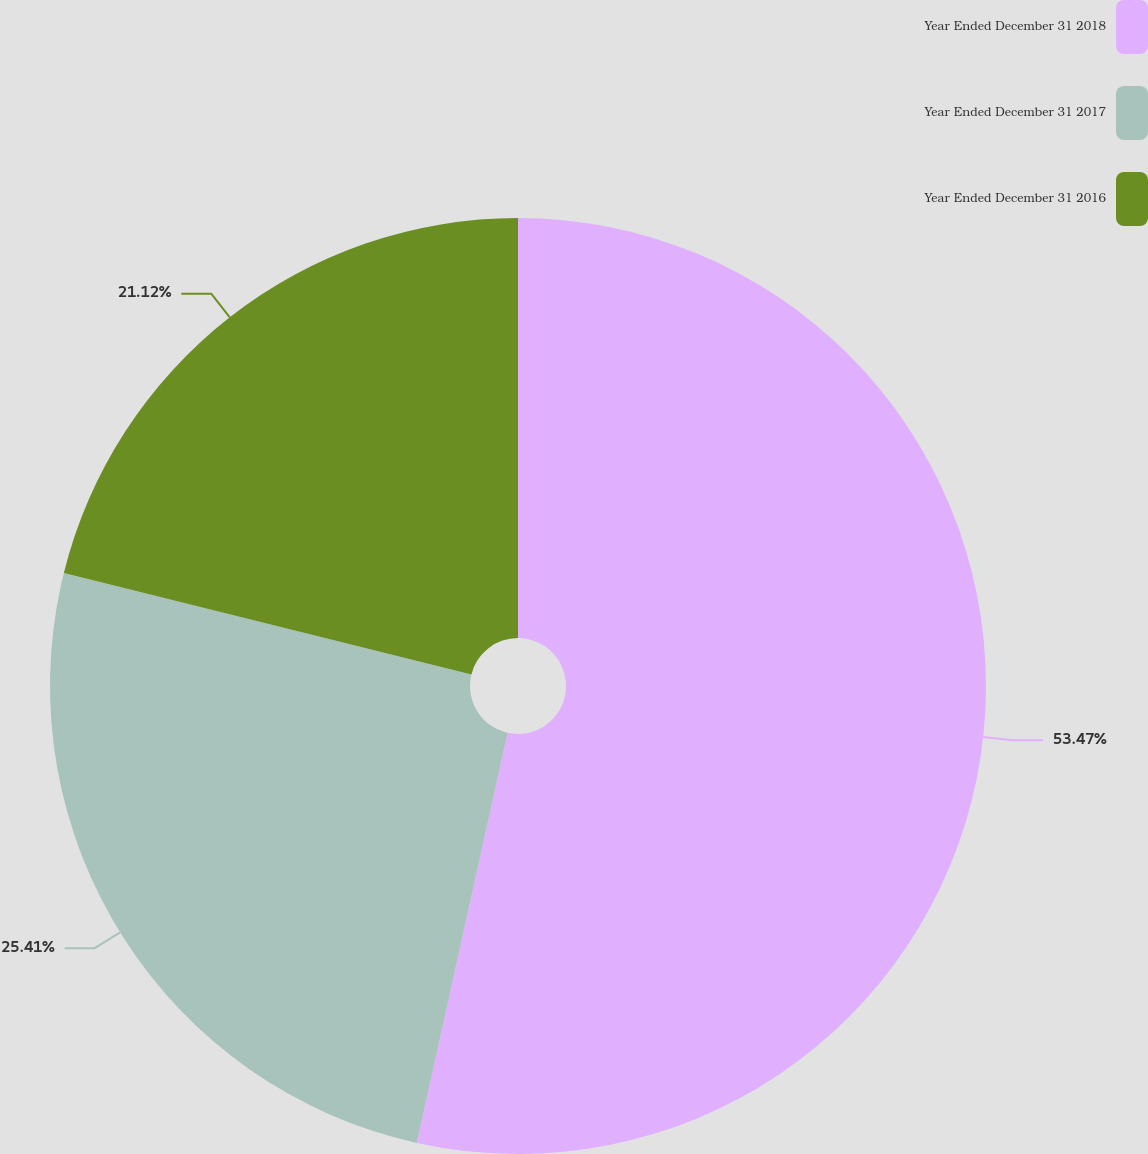<chart> <loc_0><loc_0><loc_500><loc_500><pie_chart><fcel>Year Ended December 31 2018<fcel>Year Ended December 31 2017<fcel>Year Ended December 31 2016<nl><fcel>53.47%<fcel>25.41%<fcel>21.12%<nl></chart> 